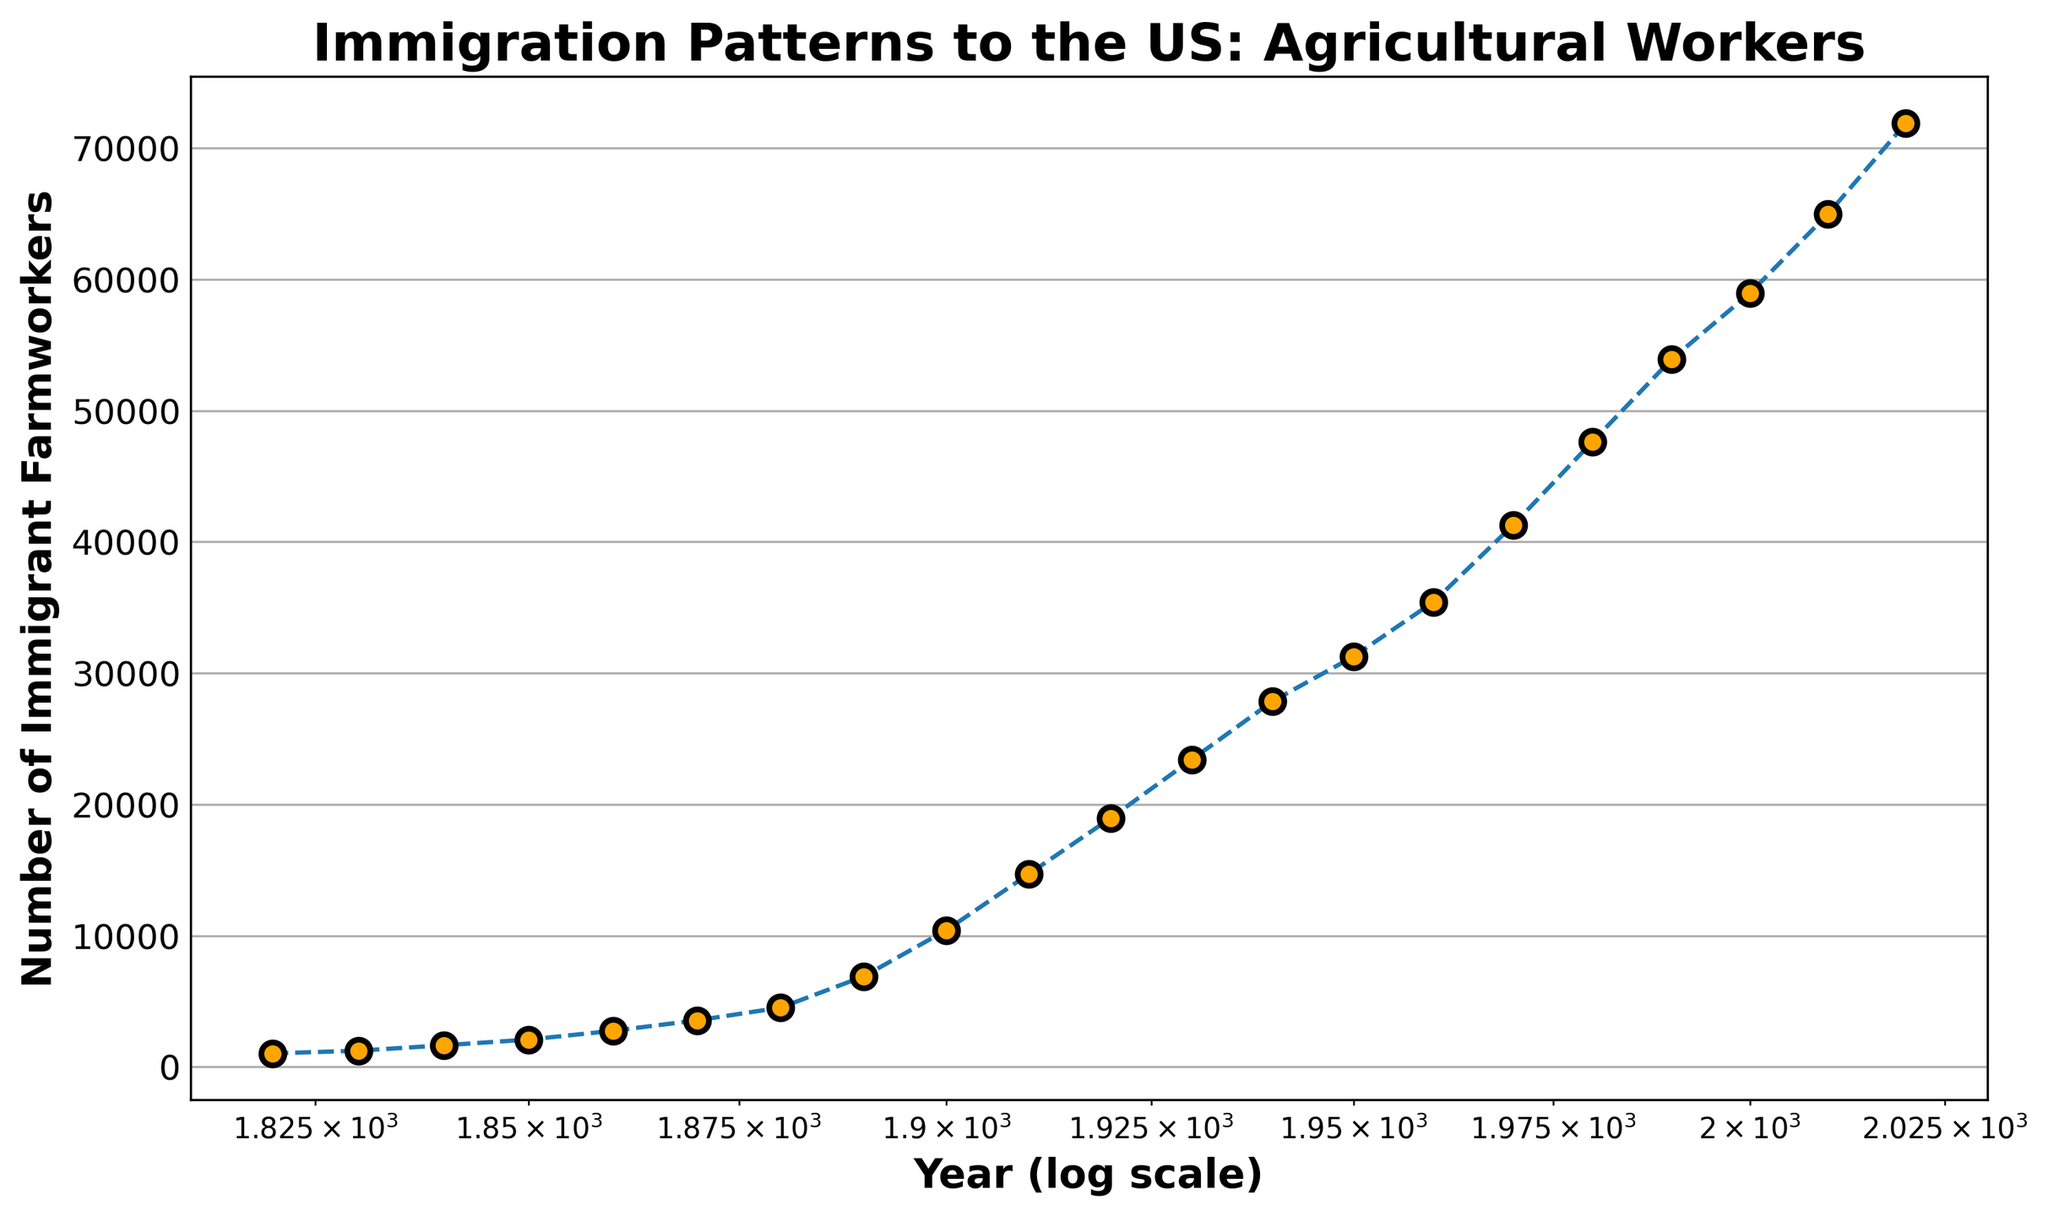What is the overall trend in the number of immigrant farmworkers from 1820 to 2020? The scatter plot with a log scale x-axis shows a clear upward trend in the number of immigrant farmworkers from 1820 to 2020. This indicates a continuous increase over the years.
Answer: Increasing trend How does the number of farmworkers in 1900 compare to that in 1950? The number of immigrant farmworkers in 1900 is about 10413, while in 1950 it is around 31245. Clearly, the number in 1950 is significantly higher than in 1900.
Answer: 1950 has more farmworkers What is the approximate difference in the number of farmworkers between 1840 and 1920? The number of immigrant farmworkers in 1840 is approximately 1643, and in 1920 it is around 18934. The difference is 18934 - 1643 = 17291.
Answer: 17291 Between which decades did the number of immigrant farmworkers experience the greatest increase? Observing the plot, the jump between 1910 (14678) and 1920 (18934) appears significant, so the decade 1910-1920 experienced the greatest increase which is 18934 - 14678 = 4256.
Answer: 1910-1920 How does the number of farmworkers in 2000 compare to that in 2020 visually? Visually, the points for 2000 and 2020 show a noticeable increase, with the number growing from about 58943 in 2000 to approximately 71892 in 2020. This shows a substantial increment.
Answer: 2020 has more farmworkers What is the average number of immigrant farmworkers in 1860, 1870, and 1880? The numbers are 2746 in 1860, 3541 in 1870, and 4511 in 1880. The average is calculated as (2746 + 3541 + 4511) / 3 = 3599.33.
Answer: 3599.33 Which is the first year to exceed 50000 immigrant farmworkers? From the plot, 1990 is the first year with over 50000 immigrant farmworkers, having approximately 53892.
Answer: 1990 How much did the number of immigrant farmworkers increase from 1980 to 2010? In 1980, the number is 47634, and in 2010, it is 64978. The increase is 64978 - 47634 = 17344.
Answer: 17344 Is there any significant visual color change in the markers over the years? The markers are consistently colored in an orange color throughout the timeline, indicating no significant color change over the years visually.
Answer: No significant color change 